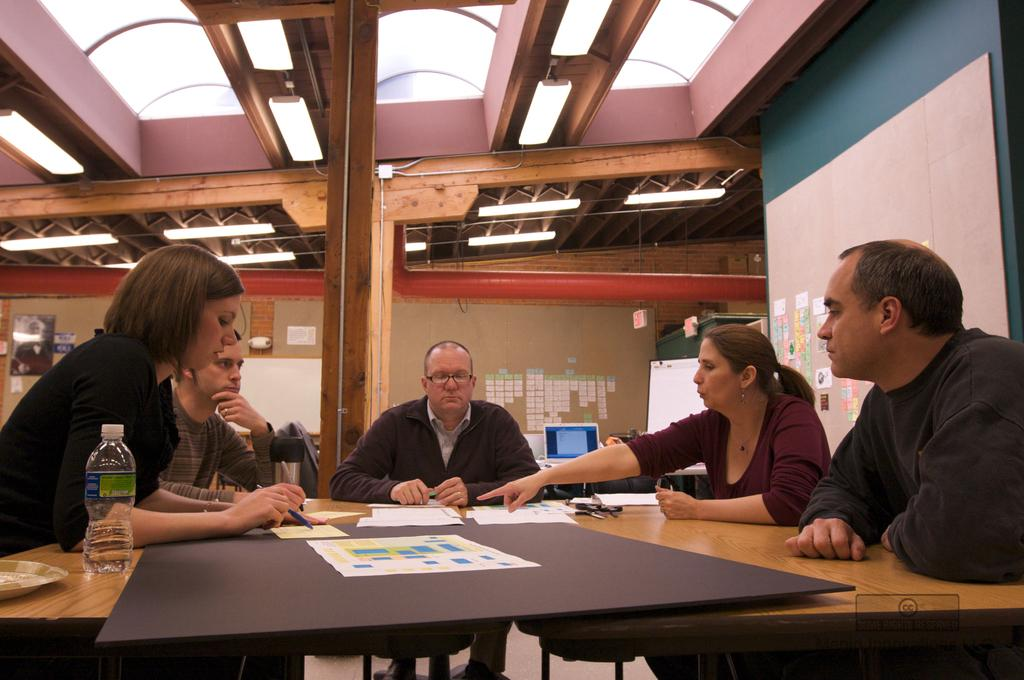How many people are sitting in the image? There are five people sitting in the image. What is the main object in the image? There is a table in the image. What items can be seen on the table? Papers and a bottle are present on the table. What type of pies are being served on the table in the image? There are no pies present in the image; only papers and a bottle are visible on the table. 